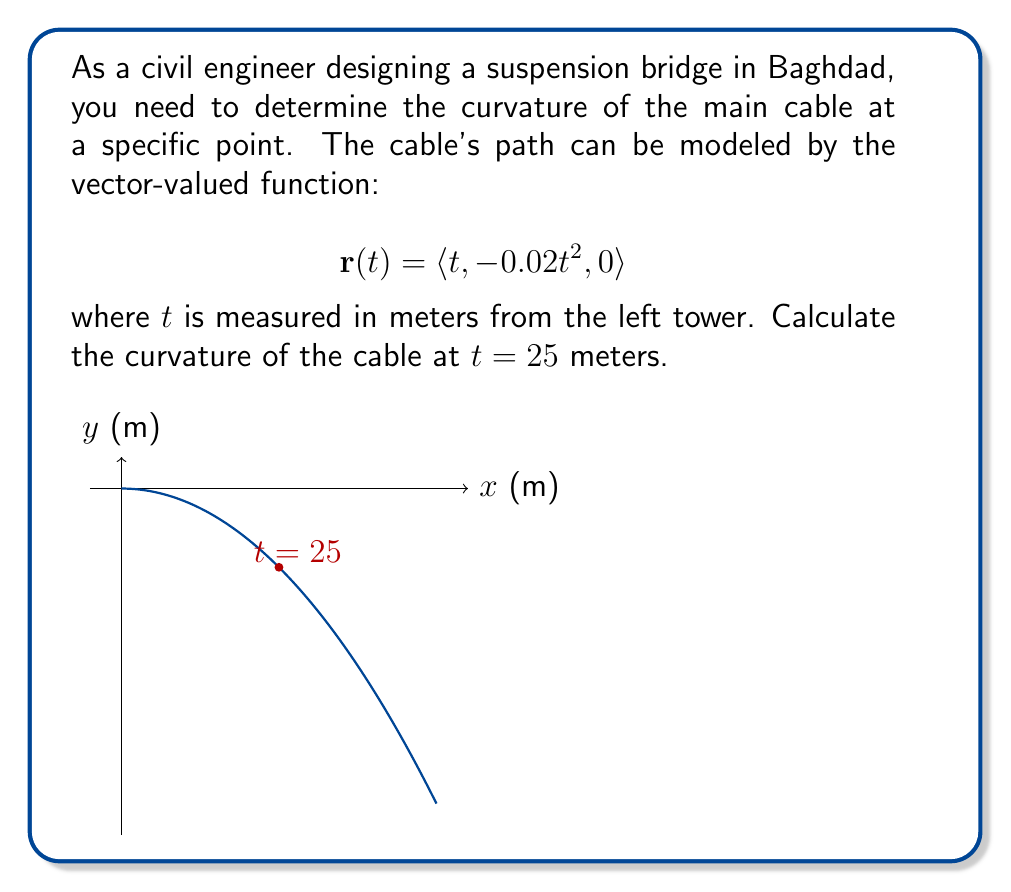Solve this math problem. To find the curvature of the cable, we'll use the formula for curvature of a vector-valued function:

$$\kappa = \frac{|\mathbf{r}'(t) \times \mathbf{r}''(t)|}{|\mathbf{r}'(t)|^3}$$

Step 1: Calculate $\mathbf{r}'(t)$
$$\mathbf{r}'(t) = \langle 1, -0.04t, 0 \rangle$$

Step 2: Calculate $\mathbf{r}''(t)$
$$\mathbf{r}''(t) = \langle 0, -0.04, 0 \rangle$$

Step 3: Calculate $\mathbf{r}'(t) \times \mathbf{r}''(t)$
$$\mathbf{r}'(t) \times \mathbf{r}''(t) = \langle 0, 0, -0.04 \rangle$$

Step 4: Calculate $|\mathbf{r}'(t) \times \mathbf{r}''(t)|$
$$|\mathbf{r}'(t) \times \mathbf{r}''(t)| = 0.04$$

Step 5: Calculate $|\mathbf{r}'(t)|$
$$|\mathbf{r}'(t)| = \sqrt{1^2 + (-0.04t)^2 + 0^2} = \sqrt{1 + 0.0016t^2}$$

Step 6: Substitute $t = 25$ into the curvature formula
$$\kappa = \frac{0.04}{(\sqrt{1 + 0.0016(25)^2})^3} = \frac{0.04}{(1.5)^3} \approx 0.0119$$
Answer: $\kappa \approx 0.0119$ m⁻¹ 